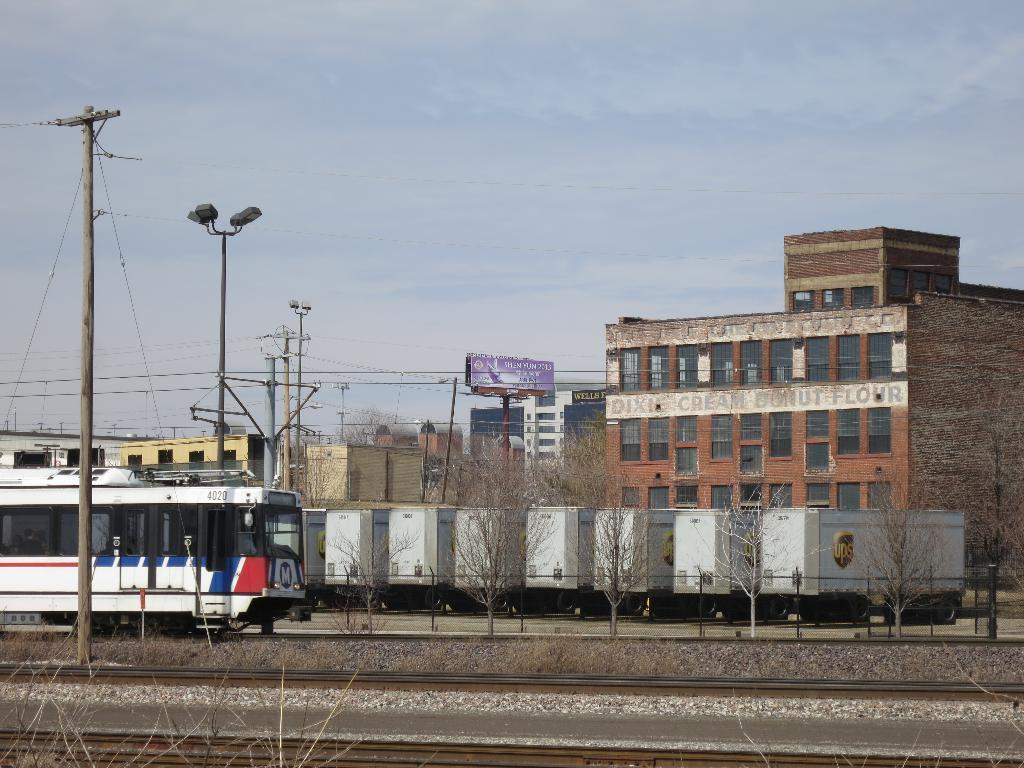What type of structures are visible in the image? There are buildings in the image. What is located in front of the buildings? There are objects in front of the buildings. What mode of transportation can be seen in the image? There is a train on a track in the image. What type of vegetation is present in the image? There are trees in the image. What type of infrastructure is visible in the image? There are utility poles in the image. What is visible in the background of the image? The sky is visible in the background of the image. How many babies are crawling on the train tracks in the image? There are no babies present in the image, and therefore no such activity can be observed. What type of mice can be seen playing with the utility poles in the image? There are no mice present in the image, and therefore no such activity can be observed. 